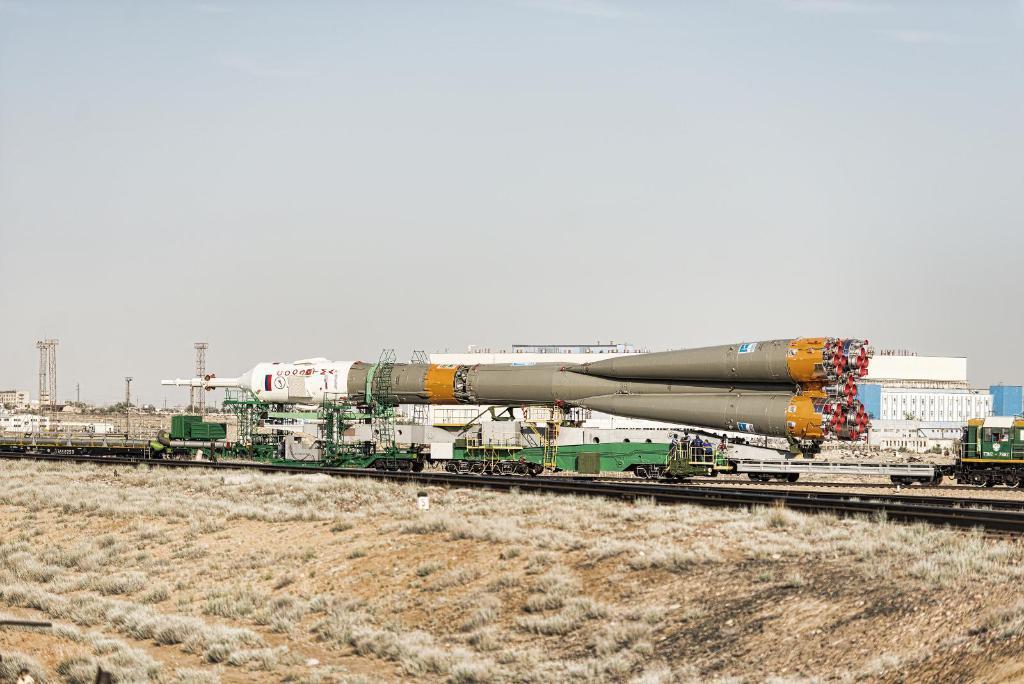Describe this image in one or two sentences. In this image, we can see buildings, towers, a satellite and we can see poles and vehicles. At the top, there is sky and at the bottom, there is dry grass. 